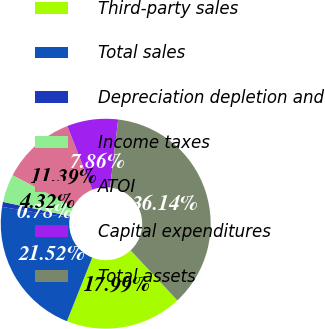Convert chart. <chart><loc_0><loc_0><loc_500><loc_500><pie_chart><fcel>Third-party sales<fcel>Total sales<fcel>Depreciation depletion and<fcel>Income taxes<fcel>ATOI<fcel>Capital expenditures<fcel>Total assets<nl><fcel>17.99%<fcel>21.52%<fcel>0.78%<fcel>4.32%<fcel>11.39%<fcel>7.86%<fcel>36.14%<nl></chart> 